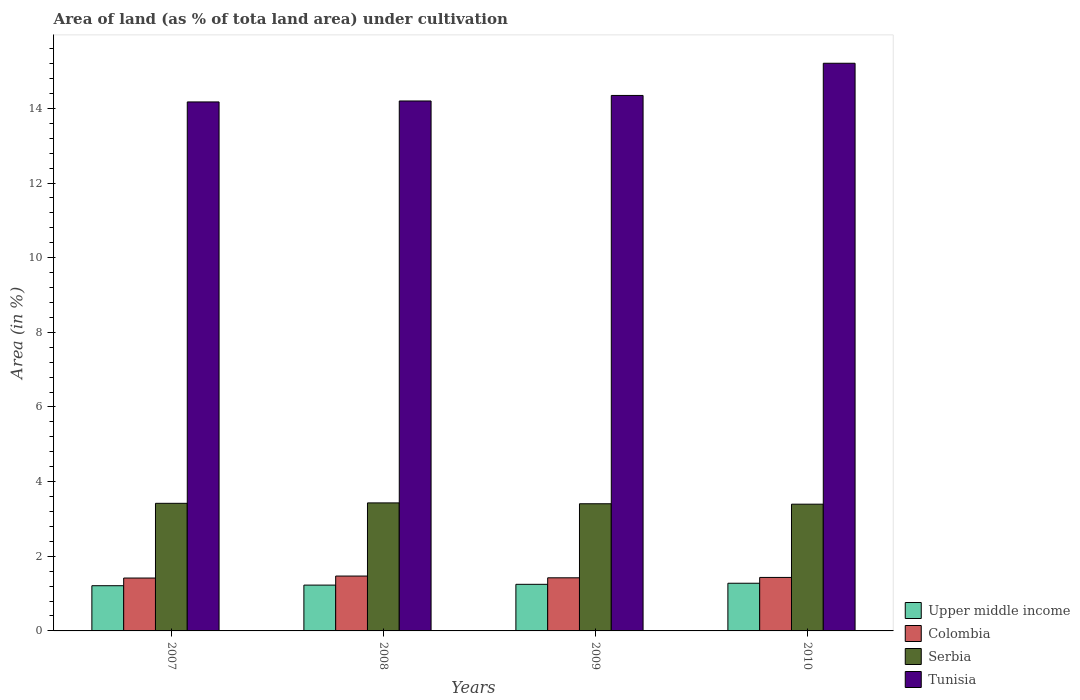How many different coloured bars are there?
Keep it short and to the point. 4. Are the number of bars per tick equal to the number of legend labels?
Make the answer very short. Yes. Are the number of bars on each tick of the X-axis equal?
Your response must be concise. Yes. What is the label of the 3rd group of bars from the left?
Your answer should be compact. 2009. What is the percentage of land under cultivation in Upper middle income in 2010?
Keep it short and to the point. 1.28. Across all years, what is the maximum percentage of land under cultivation in Serbia?
Your answer should be very brief. 3.43. Across all years, what is the minimum percentage of land under cultivation in Serbia?
Offer a terse response. 3.4. What is the total percentage of land under cultivation in Serbia in the graph?
Offer a very short reply. 13.65. What is the difference between the percentage of land under cultivation in Serbia in 2009 and that in 2010?
Give a very brief answer. 0.01. What is the difference between the percentage of land under cultivation in Colombia in 2007 and the percentage of land under cultivation in Tunisia in 2009?
Offer a very short reply. -12.93. What is the average percentage of land under cultivation in Serbia per year?
Offer a very short reply. 3.41. In the year 2009, what is the difference between the percentage of land under cultivation in Serbia and percentage of land under cultivation in Upper middle income?
Provide a succinct answer. 2.16. What is the ratio of the percentage of land under cultivation in Tunisia in 2007 to that in 2008?
Your answer should be very brief. 1. What is the difference between the highest and the second highest percentage of land under cultivation in Tunisia?
Ensure brevity in your answer.  0.86. What is the difference between the highest and the lowest percentage of land under cultivation in Upper middle income?
Ensure brevity in your answer.  0.07. Is the sum of the percentage of land under cultivation in Colombia in 2007 and 2010 greater than the maximum percentage of land under cultivation in Tunisia across all years?
Provide a succinct answer. No. What does the 4th bar from the left in 2009 represents?
Provide a succinct answer. Tunisia. What does the 2nd bar from the right in 2010 represents?
Ensure brevity in your answer.  Serbia. How many years are there in the graph?
Your response must be concise. 4. What is the difference between two consecutive major ticks on the Y-axis?
Provide a succinct answer. 2. Does the graph contain grids?
Provide a succinct answer. No. How many legend labels are there?
Make the answer very short. 4. How are the legend labels stacked?
Your response must be concise. Vertical. What is the title of the graph?
Your answer should be very brief. Area of land (as % of tota land area) under cultivation. What is the label or title of the Y-axis?
Give a very brief answer. Area (in %). What is the Area (in %) of Upper middle income in 2007?
Keep it short and to the point. 1.21. What is the Area (in %) of Colombia in 2007?
Ensure brevity in your answer.  1.42. What is the Area (in %) of Serbia in 2007?
Your answer should be compact. 3.42. What is the Area (in %) in Tunisia in 2007?
Your answer should be compact. 14.17. What is the Area (in %) in Upper middle income in 2008?
Your answer should be very brief. 1.23. What is the Area (in %) in Colombia in 2008?
Your response must be concise. 1.47. What is the Area (in %) in Serbia in 2008?
Provide a succinct answer. 3.43. What is the Area (in %) of Tunisia in 2008?
Your response must be concise. 14.2. What is the Area (in %) of Upper middle income in 2009?
Your answer should be very brief. 1.25. What is the Area (in %) in Colombia in 2009?
Make the answer very short. 1.42. What is the Area (in %) in Serbia in 2009?
Your response must be concise. 3.41. What is the Area (in %) in Tunisia in 2009?
Keep it short and to the point. 14.35. What is the Area (in %) in Upper middle income in 2010?
Give a very brief answer. 1.28. What is the Area (in %) of Colombia in 2010?
Ensure brevity in your answer.  1.43. What is the Area (in %) of Serbia in 2010?
Your answer should be very brief. 3.4. What is the Area (in %) of Tunisia in 2010?
Provide a succinct answer. 15.21. Across all years, what is the maximum Area (in %) in Upper middle income?
Provide a short and direct response. 1.28. Across all years, what is the maximum Area (in %) in Colombia?
Ensure brevity in your answer.  1.47. Across all years, what is the maximum Area (in %) of Serbia?
Your answer should be very brief. 3.43. Across all years, what is the maximum Area (in %) of Tunisia?
Offer a terse response. 15.21. Across all years, what is the minimum Area (in %) in Upper middle income?
Your answer should be compact. 1.21. Across all years, what is the minimum Area (in %) in Colombia?
Make the answer very short. 1.42. Across all years, what is the minimum Area (in %) of Serbia?
Offer a terse response. 3.4. Across all years, what is the minimum Area (in %) of Tunisia?
Your answer should be compact. 14.17. What is the total Area (in %) of Upper middle income in the graph?
Keep it short and to the point. 4.97. What is the total Area (in %) in Colombia in the graph?
Give a very brief answer. 5.74. What is the total Area (in %) of Serbia in the graph?
Make the answer very short. 13.65. What is the total Area (in %) of Tunisia in the graph?
Offer a terse response. 57.93. What is the difference between the Area (in %) of Upper middle income in 2007 and that in 2008?
Keep it short and to the point. -0.02. What is the difference between the Area (in %) in Colombia in 2007 and that in 2008?
Ensure brevity in your answer.  -0.05. What is the difference between the Area (in %) in Serbia in 2007 and that in 2008?
Provide a short and direct response. -0.01. What is the difference between the Area (in %) in Tunisia in 2007 and that in 2008?
Give a very brief answer. -0.03. What is the difference between the Area (in %) in Upper middle income in 2007 and that in 2009?
Offer a very short reply. -0.04. What is the difference between the Area (in %) in Colombia in 2007 and that in 2009?
Keep it short and to the point. -0.01. What is the difference between the Area (in %) of Serbia in 2007 and that in 2009?
Your answer should be compact. 0.01. What is the difference between the Area (in %) in Tunisia in 2007 and that in 2009?
Provide a succinct answer. -0.17. What is the difference between the Area (in %) of Upper middle income in 2007 and that in 2010?
Offer a very short reply. -0.07. What is the difference between the Area (in %) of Colombia in 2007 and that in 2010?
Provide a succinct answer. -0.02. What is the difference between the Area (in %) of Serbia in 2007 and that in 2010?
Offer a very short reply. 0.02. What is the difference between the Area (in %) in Tunisia in 2007 and that in 2010?
Ensure brevity in your answer.  -1.04. What is the difference between the Area (in %) in Upper middle income in 2008 and that in 2009?
Give a very brief answer. -0.02. What is the difference between the Area (in %) of Colombia in 2008 and that in 2009?
Ensure brevity in your answer.  0.05. What is the difference between the Area (in %) of Serbia in 2008 and that in 2009?
Offer a terse response. 0.02. What is the difference between the Area (in %) of Tunisia in 2008 and that in 2009?
Your answer should be compact. -0.15. What is the difference between the Area (in %) in Upper middle income in 2008 and that in 2010?
Your answer should be compact. -0.05. What is the difference between the Area (in %) of Colombia in 2008 and that in 2010?
Your answer should be very brief. 0.04. What is the difference between the Area (in %) in Serbia in 2008 and that in 2010?
Make the answer very short. 0.03. What is the difference between the Area (in %) of Tunisia in 2008 and that in 2010?
Make the answer very short. -1.01. What is the difference between the Area (in %) of Upper middle income in 2009 and that in 2010?
Your response must be concise. -0.03. What is the difference between the Area (in %) of Colombia in 2009 and that in 2010?
Provide a succinct answer. -0.01. What is the difference between the Area (in %) in Serbia in 2009 and that in 2010?
Provide a succinct answer. 0.01. What is the difference between the Area (in %) of Tunisia in 2009 and that in 2010?
Provide a short and direct response. -0.86. What is the difference between the Area (in %) of Upper middle income in 2007 and the Area (in %) of Colombia in 2008?
Ensure brevity in your answer.  -0.26. What is the difference between the Area (in %) in Upper middle income in 2007 and the Area (in %) in Serbia in 2008?
Offer a very short reply. -2.22. What is the difference between the Area (in %) of Upper middle income in 2007 and the Area (in %) of Tunisia in 2008?
Ensure brevity in your answer.  -12.99. What is the difference between the Area (in %) of Colombia in 2007 and the Area (in %) of Serbia in 2008?
Make the answer very short. -2.01. What is the difference between the Area (in %) of Colombia in 2007 and the Area (in %) of Tunisia in 2008?
Offer a terse response. -12.78. What is the difference between the Area (in %) of Serbia in 2007 and the Area (in %) of Tunisia in 2008?
Make the answer very short. -10.78. What is the difference between the Area (in %) of Upper middle income in 2007 and the Area (in %) of Colombia in 2009?
Your response must be concise. -0.21. What is the difference between the Area (in %) in Upper middle income in 2007 and the Area (in %) in Serbia in 2009?
Give a very brief answer. -2.2. What is the difference between the Area (in %) in Upper middle income in 2007 and the Area (in %) in Tunisia in 2009?
Offer a very short reply. -13.14. What is the difference between the Area (in %) in Colombia in 2007 and the Area (in %) in Serbia in 2009?
Give a very brief answer. -1.99. What is the difference between the Area (in %) of Colombia in 2007 and the Area (in %) of Tunisia in 2009?
Make the answer very short. -12.93. What is the difference between the Area (in %) in Serbia in 2007 and the Area (in %) in Tunisia in 2009?
Provide a succinct answer. -10.93. What is the difference between the Area (in %) of Upper middle income in 2007 and the Area (in %) of Colombia in 2010?
Offer a very short reply. -0.22. What is the difference between the Area (in %) in Upper middle income in 2007 and the Area (in %) in Serbia in 2010?
Keep it short and to the point. -2.18. What is the difference between the Area (in %) in Upper middle income in 2007 and the Area (in %) in Tunisia in 2010?
Ensure brevity in your answer.  -14. What is the difference between the Area (in %) in Colombia in 2007 and the Area (in %) in Serbia in 2010?
Your answer should be very brief. -1.98. What is the difference between the Area (in %) in Colombia in 2007 and the Area (in %) in Tunisia in 2010?
Your answer should be very brief. -13.79. What is the difference between the Area (in %) of Serbia in 2007 and the Area (in %) of Tunisia in 2010?
Offer a very short reply. -11.79. What is the difference between the Area (in %) of Upper middle income in 2008 and the Area (in %) of Colombia in 2009?
Keep it short and to the point. -0.2. What is the difference between the Area (in %) of Upper middle income in 2008 and the Area (in %) of Serbia in 2009?
Provide a succinct answer. -2.18. What is the difference between the Area (in %) in Upper middle income in 2008 and the Area (in %) in Tunisia in 2009?
Give a very brief answer. -13.12. What is the difference between the Area (in %) in Colombia in 2008 and the Area (in %) in Serbia in 2009?
Give a very brief answer. -1.94. What is the difference between the Area (in %) in Colombia in 2008 and the Area (in %) in Tunisia in 2009?
Offer a very short reply. -12.88. What is the difference between the Area (in %) of Serbia in 2008 and the Area (in %) of Tunisia in 2009?
Provide a short and direct response. -10.92. What is the difference between the Area (in %) of Upper middle income in 2008 and the Area (in %) of Colombia in 2010?
Make the answer very short. -0.21. What is the difference between the Area (in %) in Upper middle income in 2008 and the Area (in %) in Serbia in 2010?
Your answer should be compact. -2.17. What is the difference between the Area (in %) of Upper middle income in 2008 and the Area (in %) of Tunisia in 2010?
Ensure brevity in your answer.  -13.98. What is the difference between the Area (in %) of Colombia in 2008 and the Area (in %) of Serbia in 2010?
Your response must be concise. -1.93. What is the difference between the Area (in %) of Colombia in 2008 and the Area (in %) of Tunisia in 2010?
Make the answer very short. -13.74. What is the difference between the Area (in %) in Serbia in 2008 and the Area (in %) in Tunisia in 2010?
Provide a short and direct response. -11.78. What is the difference between the Area (in %) of Upper middle income in 2009 and the Area (in %) of Colombia in 2010?
Make the answer very short. -0.18. What is the difference between the Area (in %) of Upper middle income in 2009 and the Area (in %) of Serbia in 2010?
Give a very brief answer. -2.15. What is the difference between the Area (in %) in Upper middle income in 2009 and the Area (in %) in Tunisia in 2010?
Keep it short and to the point. -13.96. What is the difference between the Area (in %) in Colombia in 2009 and the Area (in %) in Serbia in 2010?
Your answer should be compact. -1.97. What is the difference between the Area (in %) in Colombia in 2009 and the Area (in %) in Tunisia in 2010?
Your answer should be very brief. -13.79. What is the difference between the Area (in %) in Serbia in 2009 and the Area (in %) in Tunisia in 2010?
Your answer should be very brief. -11.8. What is the average Area (in %) in Upper middle income per year?
Give a very brief answer. 1.24. What is the average Area (in %) in Colombia per year?
Offer a very short reply. 1.44. What is the average Area (in %) of Serbia per year?
Keep it short and to the point. 3.41. What is the average Area (in %) in Tunisia per year?
Offer a terse response. 14.48. In the year 2007, what is the difference between the Area (in %) in Upper middle income and Area (in %) in Colombia?
Offer a terse response. -0.21. In the year 2007, what is the difference between the Area (in %) in Upper middle income and Area (in %) in Serbia?
Your answer should be very brief. -2.21. In the year 2007, what is the difference between the Area (in %) of Upper middle income and Area (in %) of Tunisia?
Make the answer very short. -12.96. In the year 2007, what is the difference between the Area (in %) in Colombia and Area (in %) in Serbia?
Your answer should be compact. -2. In the year 2007, what is the difference between the Area (in %) in Colombia and Area (in %) in Tunisia?
Give a very brief answer. -12.76. In the year 2007, what is the difference between the Area (in %) in Serbia and Area (in %) in Tunisia?
Ensure brevity in your answer.  -10.75. In the year 2008, what is the difference between the Area (in %) of Upper middle income and Area (in %) of Colombia?
Provide a short and direct response. -0.24. In the year 2008, what is the difference between the Area (in %) of Upper middle income and Area (in %) of Serbia?
Offer a terse response. -2.2. In the year 2008, what is the difference between the Area (in %) of Upper middle income and Area (in %) of Tunisia?
Your answer should be very brief. -12.97. In the year 2008, what is the difference between the Area (in %) of Colombia and Area (in %) of Serbia?
Ensure brevity in your answer.  -1.96. In the year 2008, what is the difference between the Area (in %) in Colombia and Area (in %) in Tunisia?
Your response must be concise. -12.73. In the year 2008, what is the difference between the Area (in %) in Serbia and Area (in %) in Tunisia?
Keep it short and to the point. -10.77. In the year 2009, what is the difference between the Area (in %) of Upper middle income and Area (in %) of Colombia?
Keep it short and to the point. -0.17. In the year 2009, what is the difference between the Area (in %) in Upper middle income and Area (in %) in Serbia?
Provide a short and direct response. -2.16. In the year 2009, what is the difference between the Area (in %) of Upper middle income and Area (in %) of Tunisia?
Keep it short and to the point. -13.1. In the year 2009, what is the difference between the Area (in %) of Colombia and Area (in %) of Serbia?
Your answer should be compact. -1.98. In the year 2009, what is the difference between the Area (in %) of Colombia and Area (in %) of Tunisia?
Keep it short and to the point. -12.92. In the year 2009, what is the difference between the Area (in %) in Serbia and Area (in %) in Tunisia?
Provide a short and direct response. -10.94. In the year 2010, what is the difference between the Area (in %) in Upper middle income and Area (in %) in Colombia?
Make the answer very short. -0.16. In the year 2010, what is the difference between the Area (in %) in Upper middle income and Area (in %) in Serbia?
Give a very brief answer. -2.12. In the year 2010, what is the difference between the Area (in %) of Upper middle income and Area (in %) of Tunisia?
Ensure brevity in your answer.  -13.93. In the year 2010, what is the difference between the Area (in %) of Colombia and Area (in %) of Serbia?
Provide a succinct answer. -1.96. In the year 2010, what is the difference between the Area (in %) of Colombia and Area (in %) of Tunisia?
Ensure brevity in your answer.  -13.78. In the year 2010, what is the difference between the Area (in %) of Serbia and Area (in %) of Tunisia?
Your answer should be very brief. -11.81. What is the ratio of the Area (in %) in Upper middle income in 2007 to that in 2008?
Make the answer very short. 0.99. What is the ratio of the Area (in %) of Colombia in 2007 to that in 2008?
Give a very brief answer. 0.96. What is the ratio of the Area (in %) in Serbia in 2007 to that in 2008?
Your answer should be very brief. 1. What is the ratio of the Area (in %) of Tunisia in 2007 to that in 2008?
Provide a short and direct response. 1. What is the ratio of the Area (in %) in Upper middle income in 2007 to that in 2009?
Make the answer very short. 0.97. What is the ratio of the Area (in %) in Tunisia in 2007 to that in 2009?
Provide a succinct answer. 0.99. What is the ratio of the Area (in %) of Upper middle income in 2007 to that in 2010?
Provide a succinct answer. 0.95. What is the ratio of the Area (in %) in Colombia in 2007 to that in 2010?
Keep it short and to the point. 0.99. What is the ratio of the Area (in %) of Tunisia in 2007 to that in 2010?
Make the answer very short. 0.93. What is the ratio of the Area (in %) in Upper middle income in 2008 to that in 2009?
Provide a short and direct response. 0.98. What is the ratio of the Area (in %) of Colombia in 2008 to that in 2009?
Make the answer very short. 1.03. What is the ratio of the Area (in %) in Tunisia in 2008 to that in 2009?
Make the answer very short. 0.99. What is the ratio of the Area (in %) in Upper middle income in 2008 to that in 2010?
Give a very brief answer. 0.96. What is the ratio of the Area (in %) of Colombia in 2008 to that in 2010?
Make the answer very short. 1.03. What is the ratio of the Area (in %) of Tunisia in 2008 to that in 2010?
Your response must be concise. 0.93. What is the ratio of the Area (in %) in Upper middle income in 2009 to that in 2010?
Give a very brief answer. 0.98. What is the ratio of the Area (in %) in Colombia in 2009 to that in 2010?
Keep it short and to the point. 0.99. What is the ratio of the Area (in %) in Serbia in 2009 to that in 2010?
Ensure brevity in your answer.  1. What is the ratio of the Area (in %) of Tunisia in 2009 to that in 2010?
Give a very brief answer. 0.94. What is the difference between the highest and the second highest Area (in %) of Upper middle income?
Provide a succinct answer. 0.03. What is the difference between the highest and the second highest Area (in %) of Colombia?
Give a very brief answer. 0.04. What is the difference between the highest and the second highest Area (in %) of Serbia?
Give a very brief answer. 0.01. What is the difference between the highest and the second highest Area (in %) in Tunisia?
Make the answer very short. 0.86. What is the difference between the highest and the lowest Area (in %) in Upper middle income?
Provide a short and direct response. 0.07. What is the difference between the highest and the lowest Area (in %) in Colombia?
Make the answer very short. 0.05. What is the difference between the highest and the lowest Area (in %) of Serbia?
Your answer should be very brief. 0.03. What is the difference between the highest and the lowest Area (in %) of Tunisia?
Offer a very short reply. 1.04. 